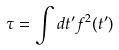Convert formula to latex. <formula><loc_0><loc_0><loc_500><loc_500>\tau = \int d t ^ { \prime } f ^ { 2 } ( t ^ { \prime } )</formula> 